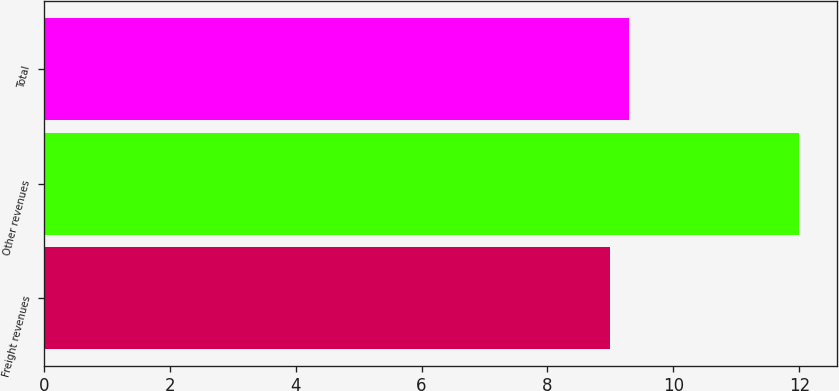Convert chart to OTSL. <chart><loc_0><loc_0><loc_500><loc_500><bar_chart><fcel>Freight revenues<fcel>Other revenues<fcel>Total<nl><fcel>9<fcel>12<fcel>9.3<nl></chart> 